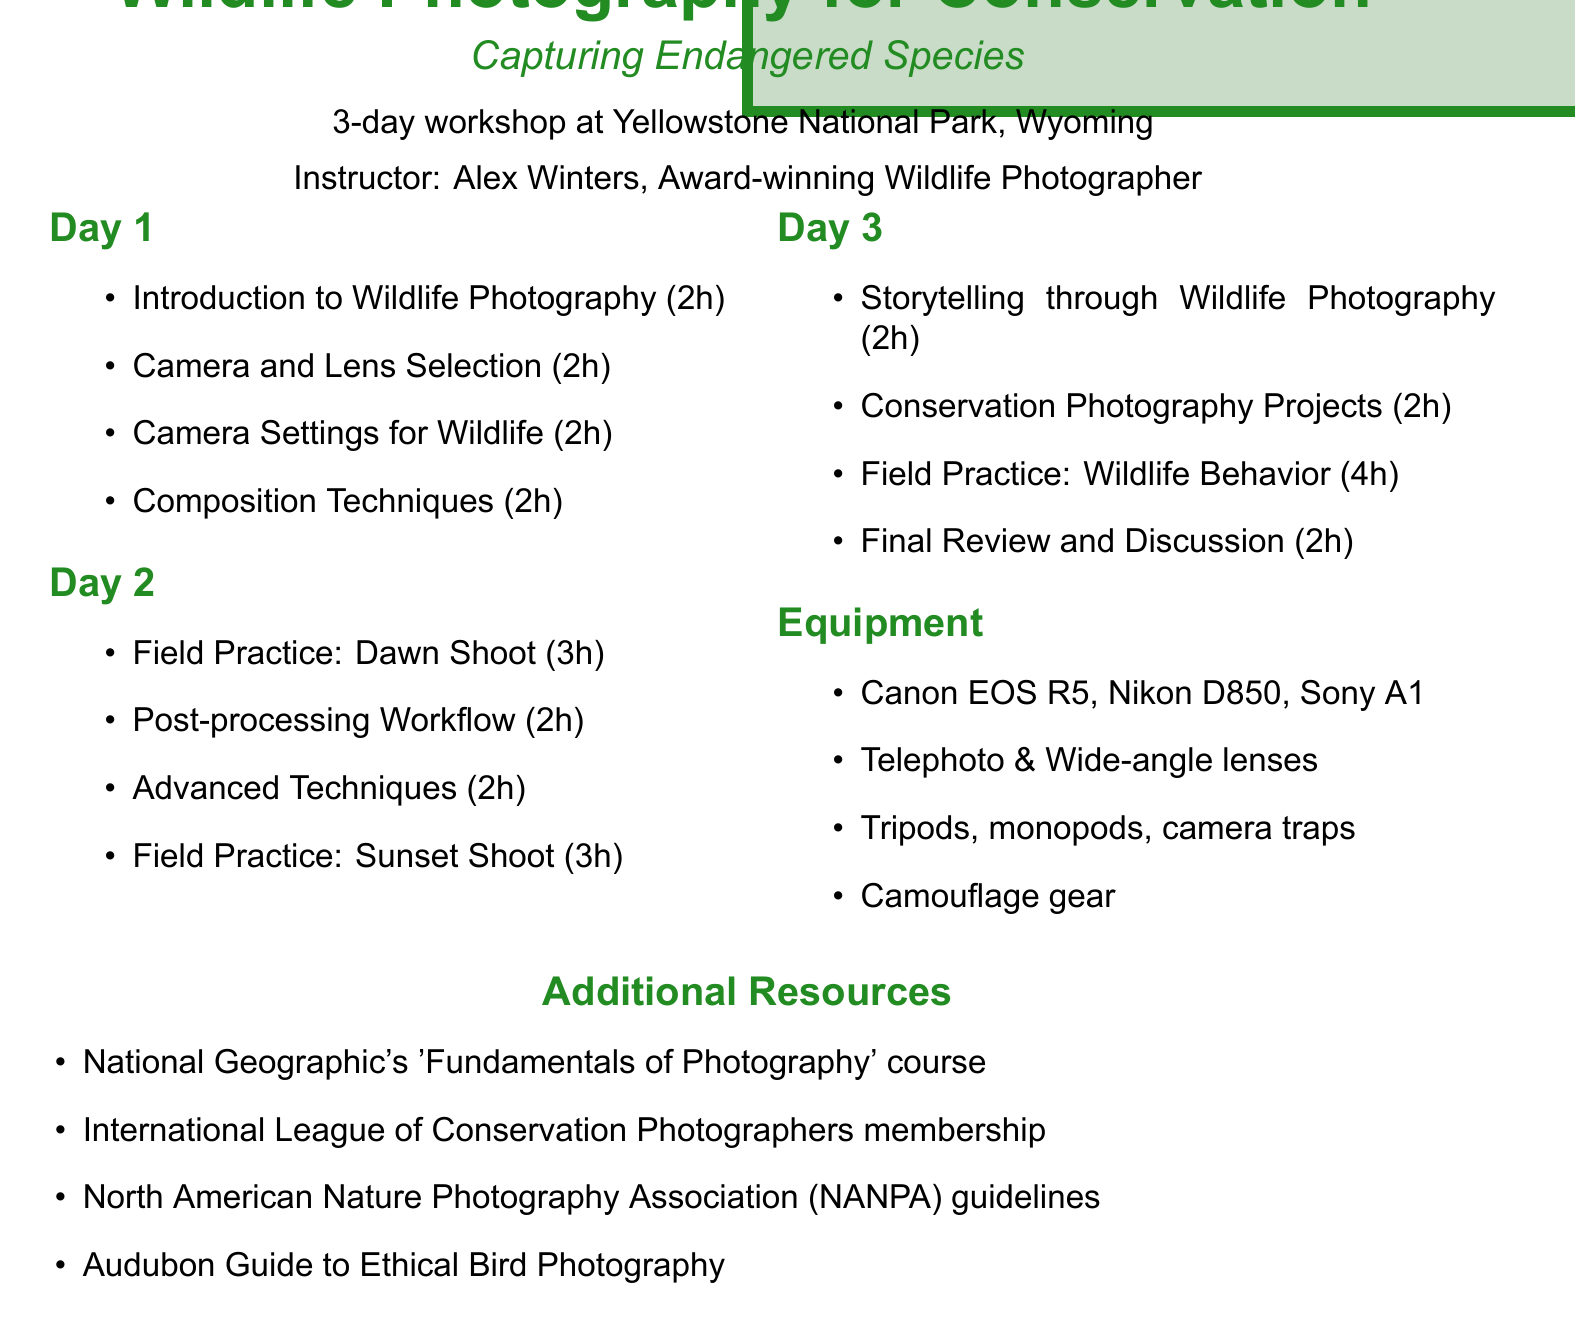What is the title of the workshop? The title is mentioned at the beginning of the document.
Answer: Wildlife Photography for Conservation: Capturing Endangered Species Who is the instructor of the workshop? The instructor's name is stated in the introductory part of the document.
Answer: Alex Winters How many days is the workshop? The duration of the workshop is specified.
Answer: 3-day workshop What is the location of the workshop? The location is explicitly mentioned in the document.
Answer: Yellowstone National Park, Wyoming Which camera is included in the equipment list? The document states several types of equipment, including cameras.
Answer: Canon EOS R5 mirrorless camera What session focuses on photographing wolves and grizzly bears? One of the sessions provides a specific focus for field practice.
Answer: Field Practice: Dawn Shoot What is the duration of the session on "Camera Settings for Wildlife"? The document provides details about the duration of various sessions.
Answer: 2 hours What additional resource is mentioned for photography basics? The document lists several resources for attendees.
Answer: National Geographic's 'Fundamentals of Photography' course What session discusses creating photo essays? The document describes sessions focused on storytelling in wildlife photography.
Answer: Storytelling through Wildlife Photography 